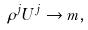<formula> <loc_0><loc_0><loc_500><loc_500>\rho ^ { j } U ^ { j } \rightarrow m ,</formula> 